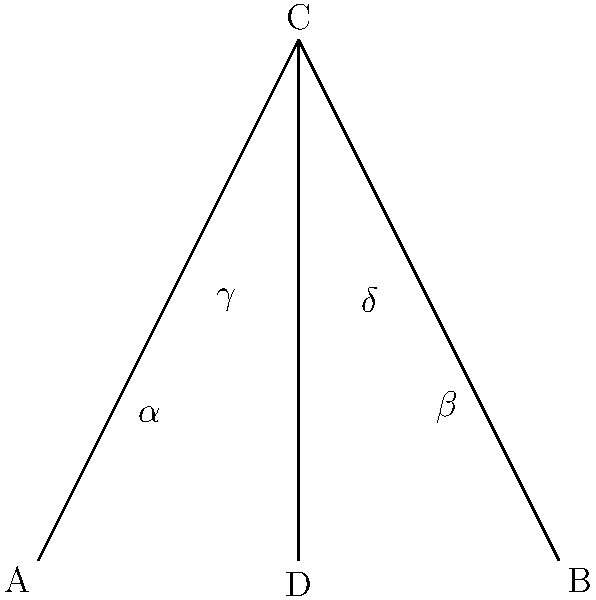In this abstract art piece, intersecting lines form various angles. If $\alpha + \beta = 90°$ and $\gamma + \delta = 90°$, what symbolic interpretation could be drawn about the relationship between these angles and the artist's inner conflict? To analyze this abstract art piece from a psychological perspective, we can follow these steps:

1. Geometric observation: The diagram shows two intersecting lines forming four angles at point C.

2. Given information: We know that $\alpha + \beta = 90°$ and $\gamma + \delta = 90°$.

3. Geometric principle: When two lines intersect, opposite angles are equal. Therefore, $\alpha = \delta$ and $\beta = \gamma$.

4. Symbolic interpretation:
   a) The 90° sum represents completeness or wholeness in many cultures.
   b) The division into two pairs of angles could symbolize duality or opposing forces.
   c) The equality of opposite angles might represent balance or interconnectedness.

5. Psychological analysis:
   a) The artist may be exploring the concept of inner conflict through these intersecting lines.
   b) The equal pairs of angles ($\alpha = \delta$ and $\beta = \gamma$) could represent different aspects of the artist's psyche in tension.
   c) The 90° sums ($\alpha + \beta = 90°$ and $\gamma + \delta = 90°$) might symbolize the artist's desire for wholeness or resolution of internal conflicts.

6. Deeper meaning:
   The artwork could be interpreted as a visual representation of the artist's struggle to find balance between opposing internal forces, while striving for a sense of completeness or integration of the self.
Answer: The angles symbolize internal conflict and the search for psychological balance and wholeness. 